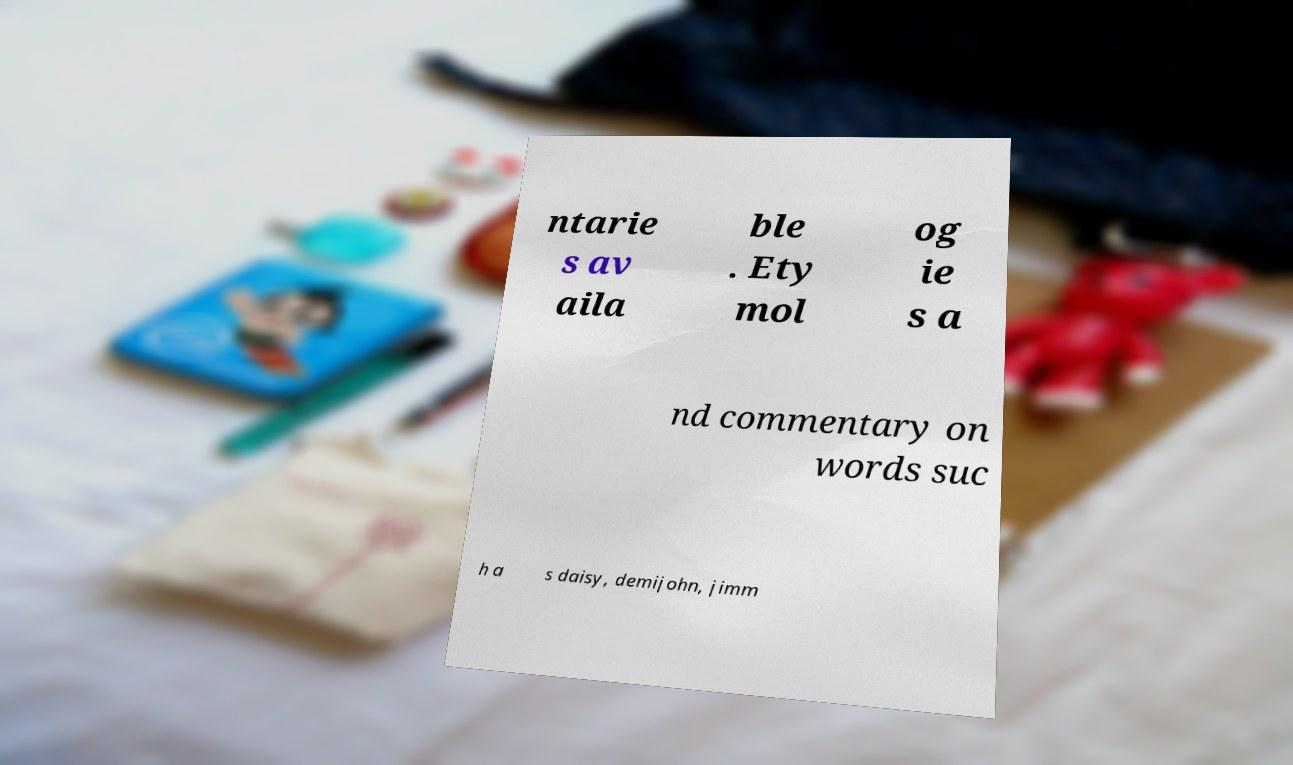For documentation purposes, I need the text within this image transcribed. Could you provide that? ntarie s av aila ble . Ety mol og ie s a nd commentary on words suc h a s daisy, demijohn, jimm 